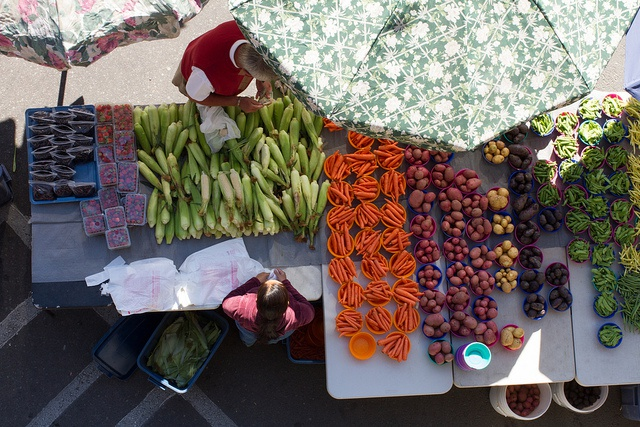Describe the objects in this image and their specific colors. I can see umbrella in lightgray, ivory, darkgray, and beige tones, carrot in lightgray, brown, red, and maroon tones, umbrella in lightgray, gray, and darkgray tones, people in lightgray, maroon, darkgray, black, and gray tones, and people in lightgray, black, maroon, lightpink, and brown tones in this image. 